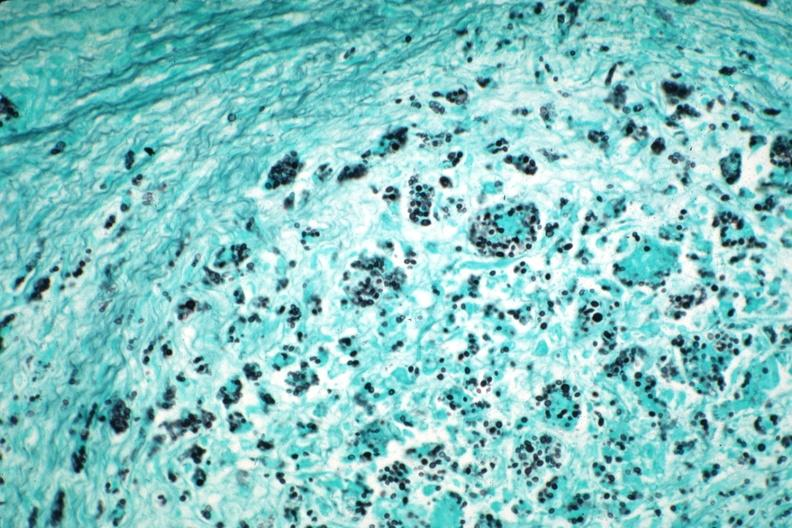what is present?
Answer the question using a single word or phrase. Pneumocystis 